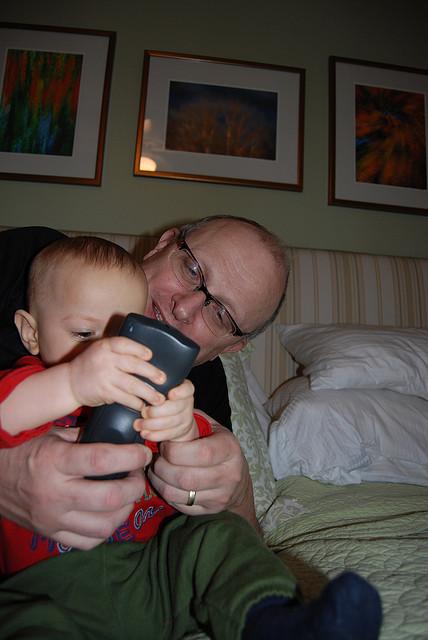Is this man married?
Short answer required. Yes. What is hanging on the wall?
Answer briefly. Pictures. What is the child playing with?
Write a very short answer. Remote. 